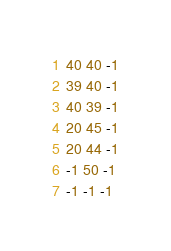Convert code to text. <code><loc_0><loc_0><loc_500><loc_500><_Ruby_>40 40 -1
39 40 -1
40 39 -1
20 45 -1
20 44 -1
-1 50 -1
-1 -1 -1
</code> 